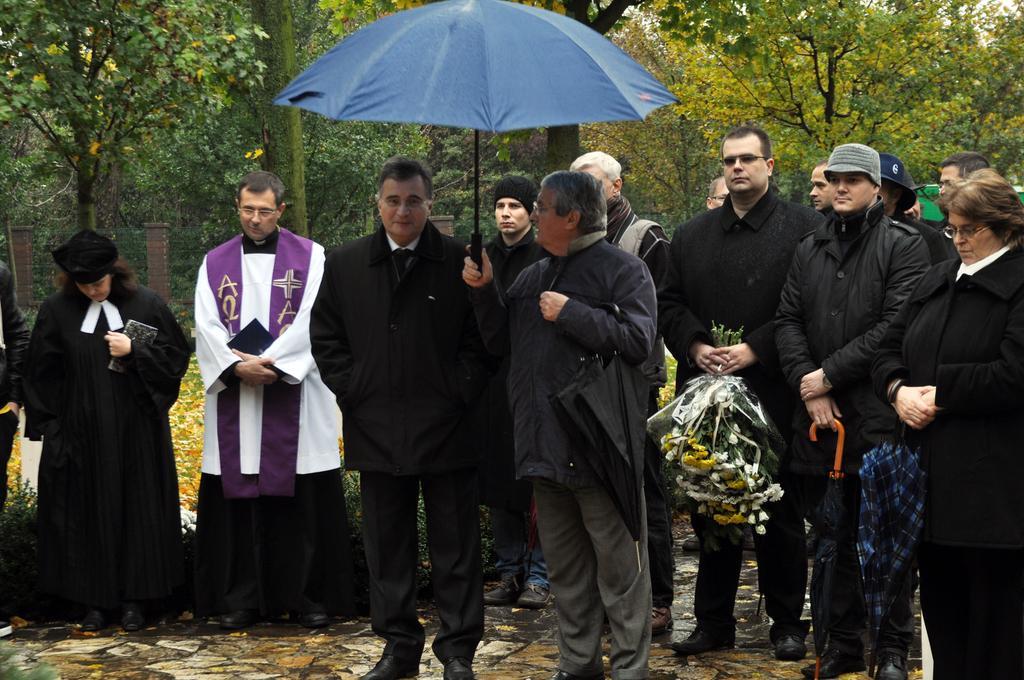Could you give a brief overview of what you see in this image? In this image there is a group of persons are standing as we can see in the middle of this image. The person standing in middle is holding an umbrella,and the person standing right side to him is holding some flowers , and the persons standing on the right side of this image are holding an umbrellas. There are some trees in the background. There is a wall behind to these persons. 